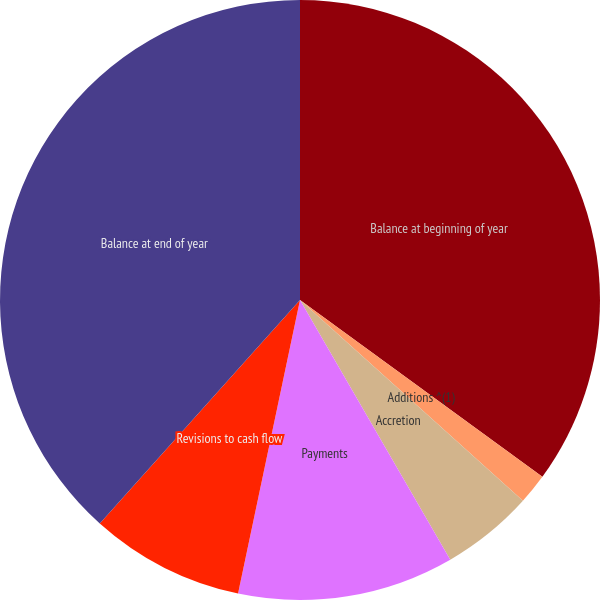Convert chart. <chart><loc_0><loc_0><loc_500><loc_500><pie_chart><fcel>Balance at beginning of year<fcel>Additions ^(1)<fcel>Accretion<fcel>Payments<fcel>Revisions to cash flow<fcel>Balance at end of year<nl><fcel>35.03%<fcel>1.64%<fcel>4.98%<fcel>11.66%<fcel>8.32%<fcel>38.37%<nl></chart> 